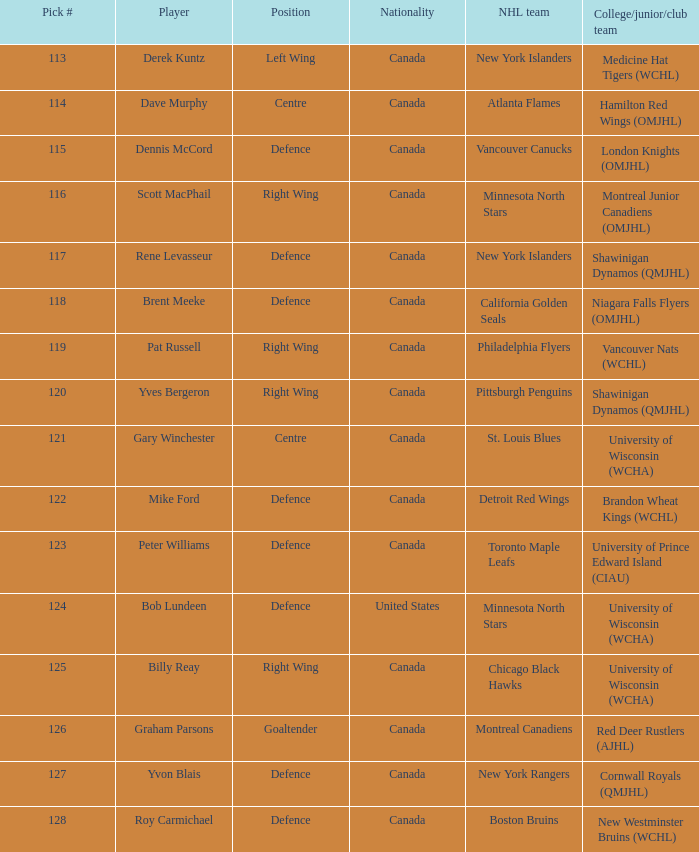Name the college/junior/club team for left wing Medicine Hat Tigers (WCHL). Would you mind parsing the complete table? {'header': ['Pick #', 'Player', 'Position', 'Nationality', 'NHL team', 'College/junior/club team'], 'rows': [['113', 'Derek Kuntz', 'Left Wing', 'Canada', 'New York Islanders', 'Medicine Hat Tigers (WCHL)'], ['114', 'Dave Murphy', 'Centre', 'Canada', 'Atlanta Flames', 'Hamilton Red Wings (OMJHL)'], ['115', 'Dennis McCord', 'Defence', 'Canada', 'Vancouver Canucks', 'London Knights (OMJHL)'], ['116', 'Scott MacPhail', 'Right Wing', 'Canada', 'Minnesota North Stars', 'Montreal Junior Canadiens (OMJHL)'], ['117', 'Rene Levasseur', 'Defence', 'Canada', 'New York Islanders', 'Shawinigan Dynamos (QMJHL)'], ['118', 'Brent Meeke', 'Defence', 'Canada', 'California Golden Seals', 'Niagara Falls Flyers (OMJHL)'], ['119', 'Pat Russell', 'Right Wing', 'Canada', 'Philadelphia Flyers', 'Vancouver Nats (WCHL)'], ['120', 'Yves Bergeron', 'Right Wing', 'Canada', 'Pittsburgh Penguins', 'Shawinigan Dynamos (QMJHL)'], ['121', 'Gary Winchester', 'Centre', 'Canada', 'St. Louis Blues', 'University of Wisconsin (WCHA)'], ['122', 'Mike Ford', 'Defence', 'Canada', 'Detroit Red Wings', 'Brandon Wheat Kings (WCHL)'], ['123', 'Peter Williams', 'Defence', 'Canada', 'Toronto Maple Leafs', 'University of Prince Edward Island (CIAU)'], ['124', 'Bob Lundeen', 'Defence', 'United States', 'Minnesota North Stars', 'University of Wisconsin (WCHA)'], ['125', 'Billy Reay', 'Right Wing', 'Canada', 'Chicago Black Hawks', 'University of Wisconsin (WCHA)'], ['126', 'Graham Parsons', 'Goaltender', 'Canada', 'Montreal Canadiens', 'Red Deer Rustlers (AJHL)'], ['127', 'Yvon Blais', 'Defence', 'Canada', 'New York Rangers', 'Cornwall Royals (QMJHL)'], ['128', 'Roy Carmichael', 'Defence', 'Canada', 'Boston Bruins', 'New Westminster Bruins (WCHL)']]} 